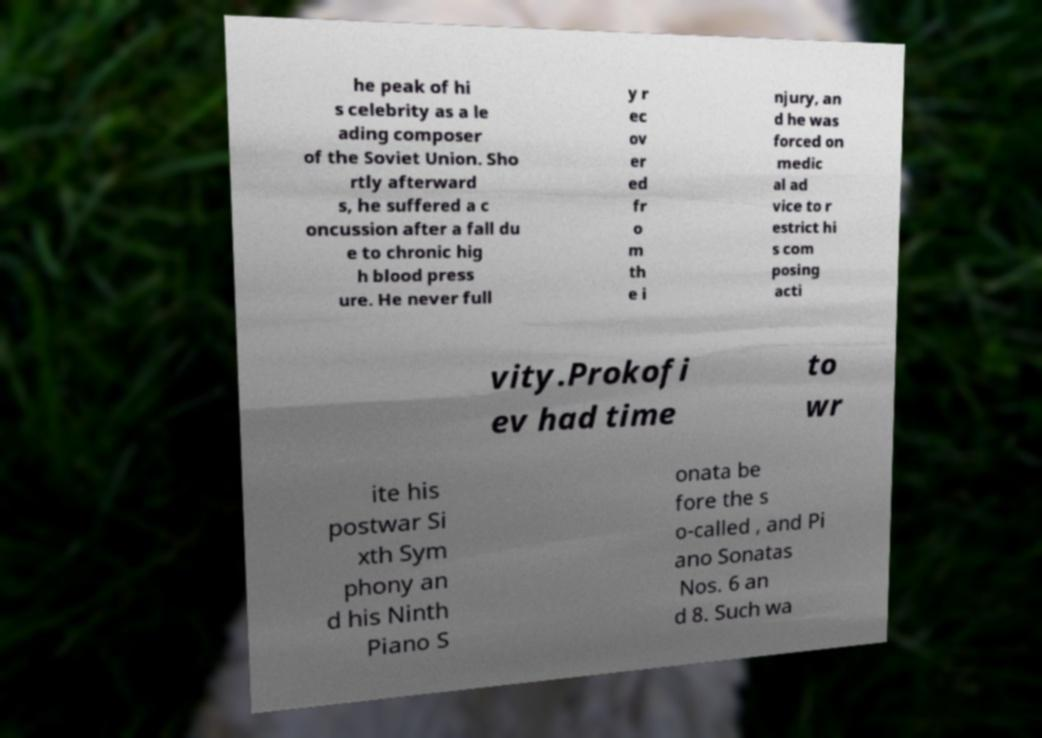Could you extract and type out the text from this image? he peak of hi s celebrity as a le ading composer of the Soviet Union. Sho rtly afterward s, he suffered a c oncussion after a fall du e to chronic hig h blood press ure. He never full y r ec ov er ed fr o m th e i njury, an d he was forced on medic al ad vice to r estrict hi s com posing acti vity.Prokofi ev had time to wr ite his postwar Si xth Sym phony an d his Ninth Piano S onata be fore the s o-called , and Pi ano Sonatas Nos. 6 an d 8. Such wa 